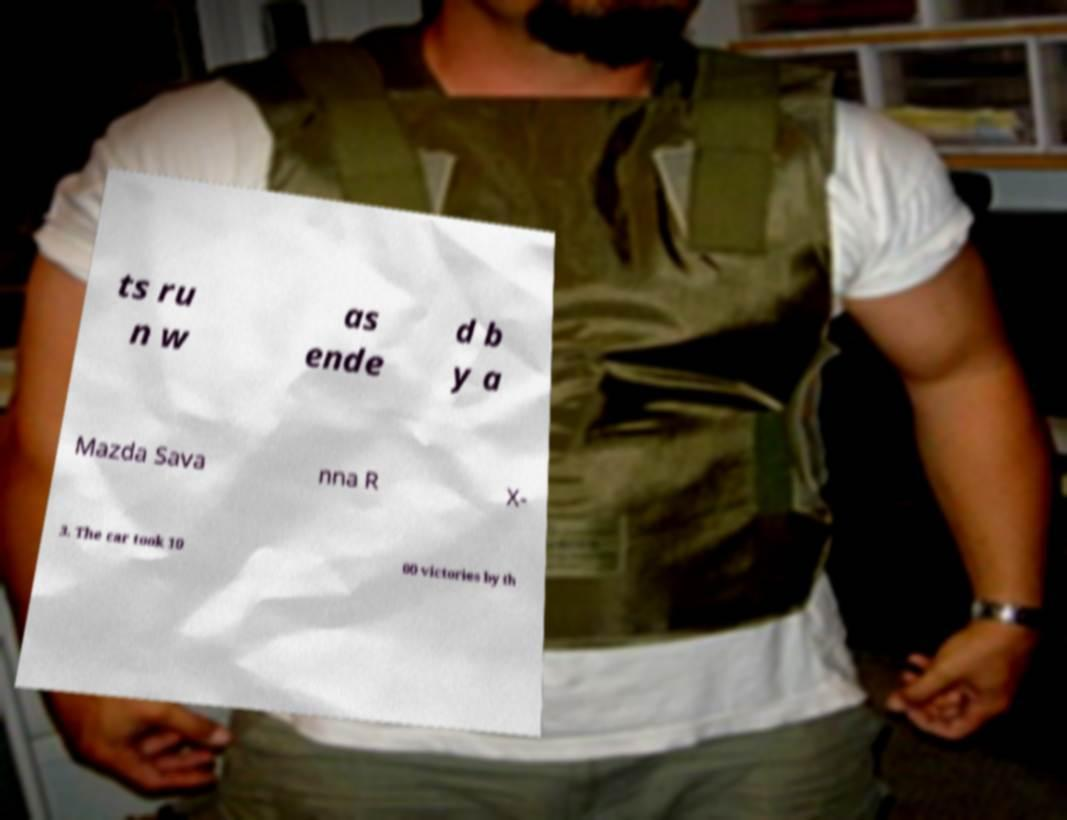What messages or text are displayed in this image? I need them in a readable, typed format. ts ru n w as ende d b y a Mazda Sava nna R X- 3. The car took 10 00 victories by th 